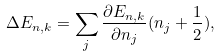<formula> <loc_0><loc_0><loc_500><loc_500>\Delta E _ { n , { k } } = \sum _ { j } { \frac { \partial E _ { n , { k } } } { \partial n _ { j } } } ( n _ { j } + { \frac { 1 } { 2 } } ) ,</formula> 